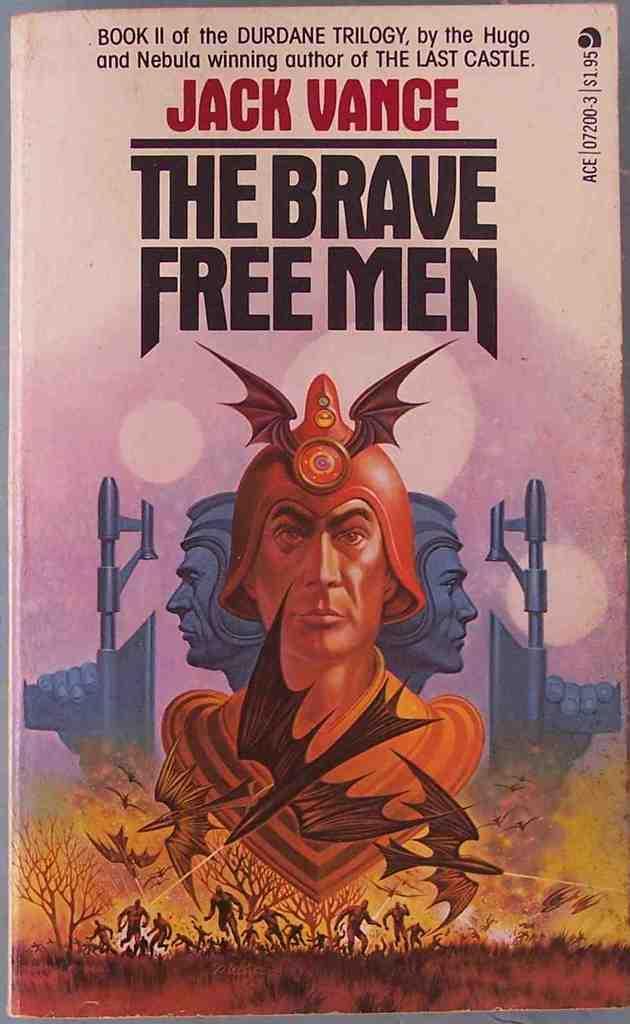Can you describe this image briefly? In this image we can see a book. On the book we can see text and image of persons, grass and the trees. 